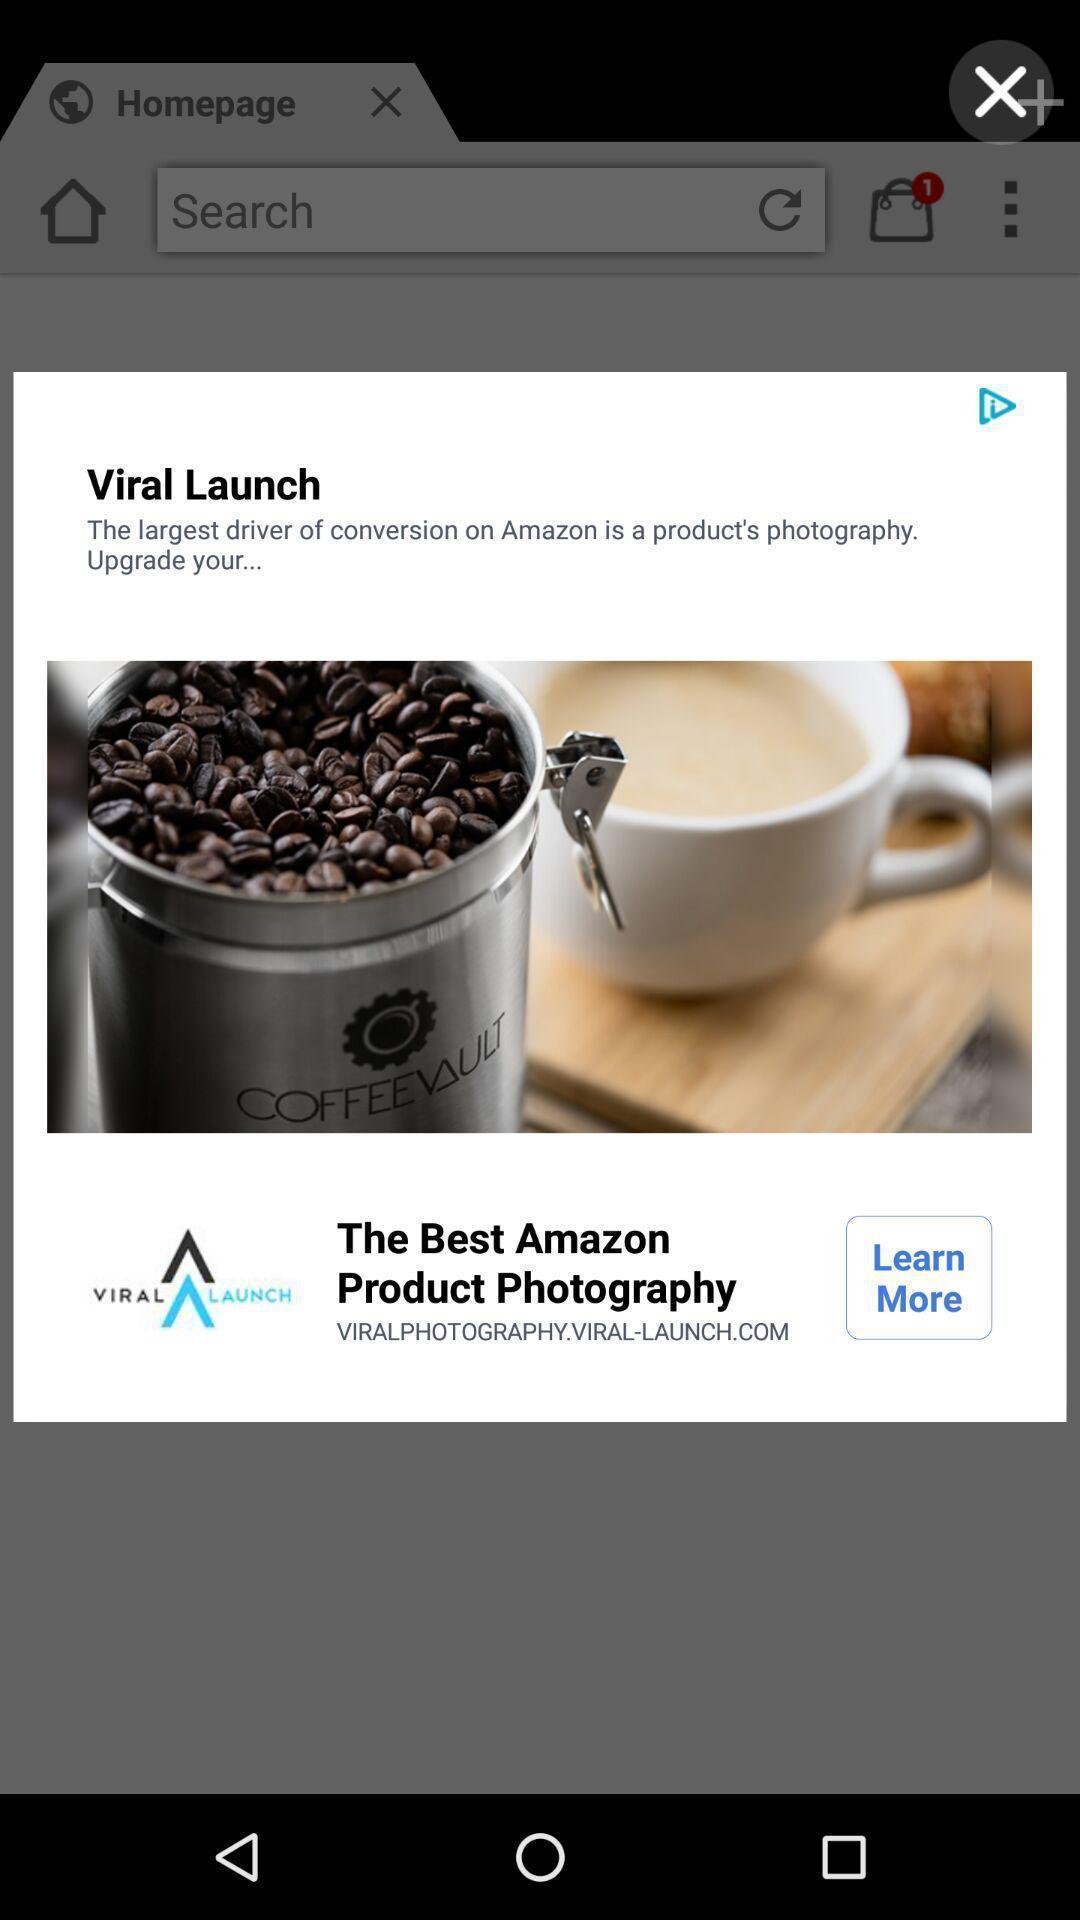Provide a detailed account of this screenshot. Pop-up showing the coffee with texts. 